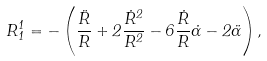Convert formula to latex. <formula><loc_0><loc_0><loc_500><loc_500>R _ { 1 } ^ { 1 } = - \left ( \frac { \ddot { R } } { R } + 2 \frac { \dot { R } ^ { 2 } } { R ^ { 2 } } - 6 \frac { \dot { R } } { R } \dot { \alpha } - 2 \ddot { \alpha } \right ) ,</formula> 